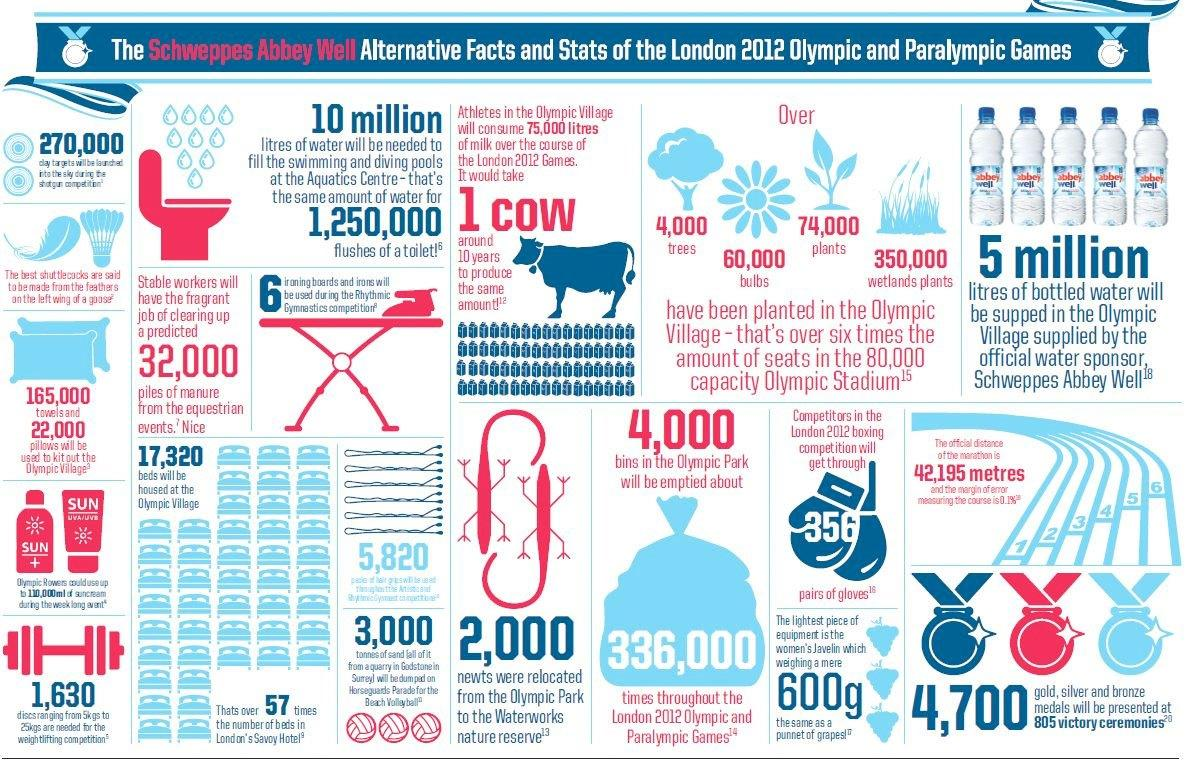Draw attention to some important aspects in this diagram. Schweppes Abbey Well is the official water sponsor for the Olympic village. At the Aquatic Centre of the Olympic games, 10 million liters of water is required. 74,000 plants were planted in the Olympic village. It would take approximately 10 years for a cow to produce 75,000 liters of milk. The clearance of 32,000 piles of manure by stable workers is required. 